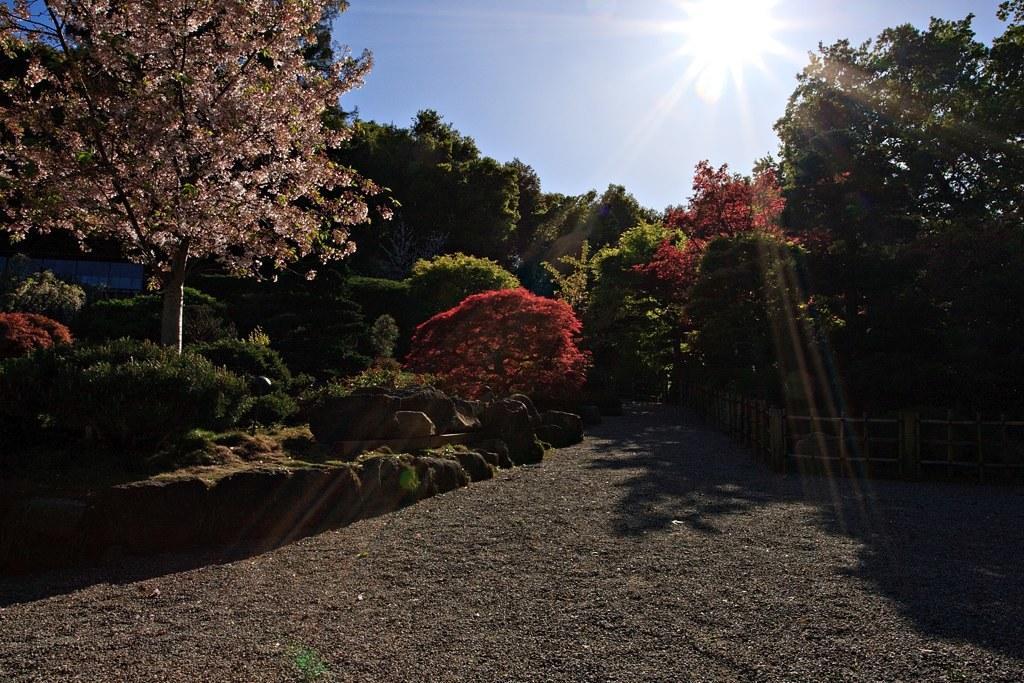In one or two sentences, can you explain what this image depicts? In this picture I can see few trees, plants and I can see sunlight in the blue sky and I can see fence. 